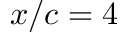Convert formula to latex. <formula><loc_0><loc_0><loc_500><loc_500>x / c = 4</formula> 